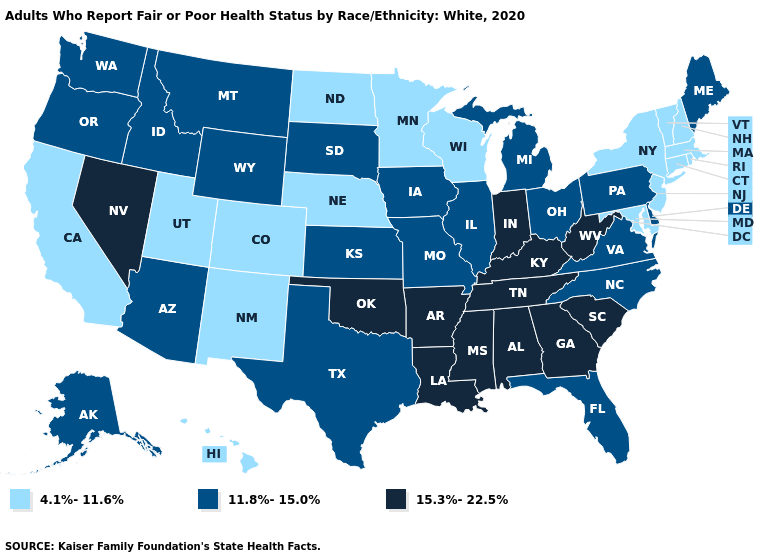What is the value of Pennsylvania?
Be succinct. 11.8%-15.0%. What is the value of Wyoming?
Answer briefly. 11.8%-15.0%. Name the states that have a value in the range 11.8%-15.0%?
Short answer required. Alaska, Arizona, Delaware, Florida, Idaho, Illinois, Iowa, Kansas, Maine, Michigan, Missouri, Montana, North Carolina, Ohio, Oregon, Pennsylvania, South Dakota, Texas, Virginia, Washington, Wyoming. Does Tennessee have the same value as Colorado?
Give a very brief answer. No. What is the value of Montana?
Quick response, please. 11.8%-15.0%. How many symbols are there in the legend?
Keep it brief. 3. What is the lowest value in the USA?
Short answer required. 4.1%-11.6%. Does Tennessee have the lowest value in the South?
Be succinct. No. What is the lowest value in the MidWest?
Write a very short answer. 4.1%-11.6%. What is the highest value in the USA?
Short answer required. 15.3%-22.5%. Name the states that have a value in the range 15.3%-22.5%?
Short answer required. Alabama, Arkansas, Georgia, Indiana, Kentucky, Louisiana, Mississippi, Nevada, Oklahoma, South Carolina, Tennessee, West Virginia. Does Colorado have the lowest value in the USA?
Give a very brief answer. Yes. Name the states that have a value in the range 15.3%-22.5%?
Keep it brief. Alabama, Arkansas, Georgia, Indiana, Kentucky, Louisiana, Mississippi, Nevada, Oklahoma, South Carolina, Tennessee, West Virginia. What is the value of Arkansas?
Give a very brief answer. 15.3%-22.5%. 